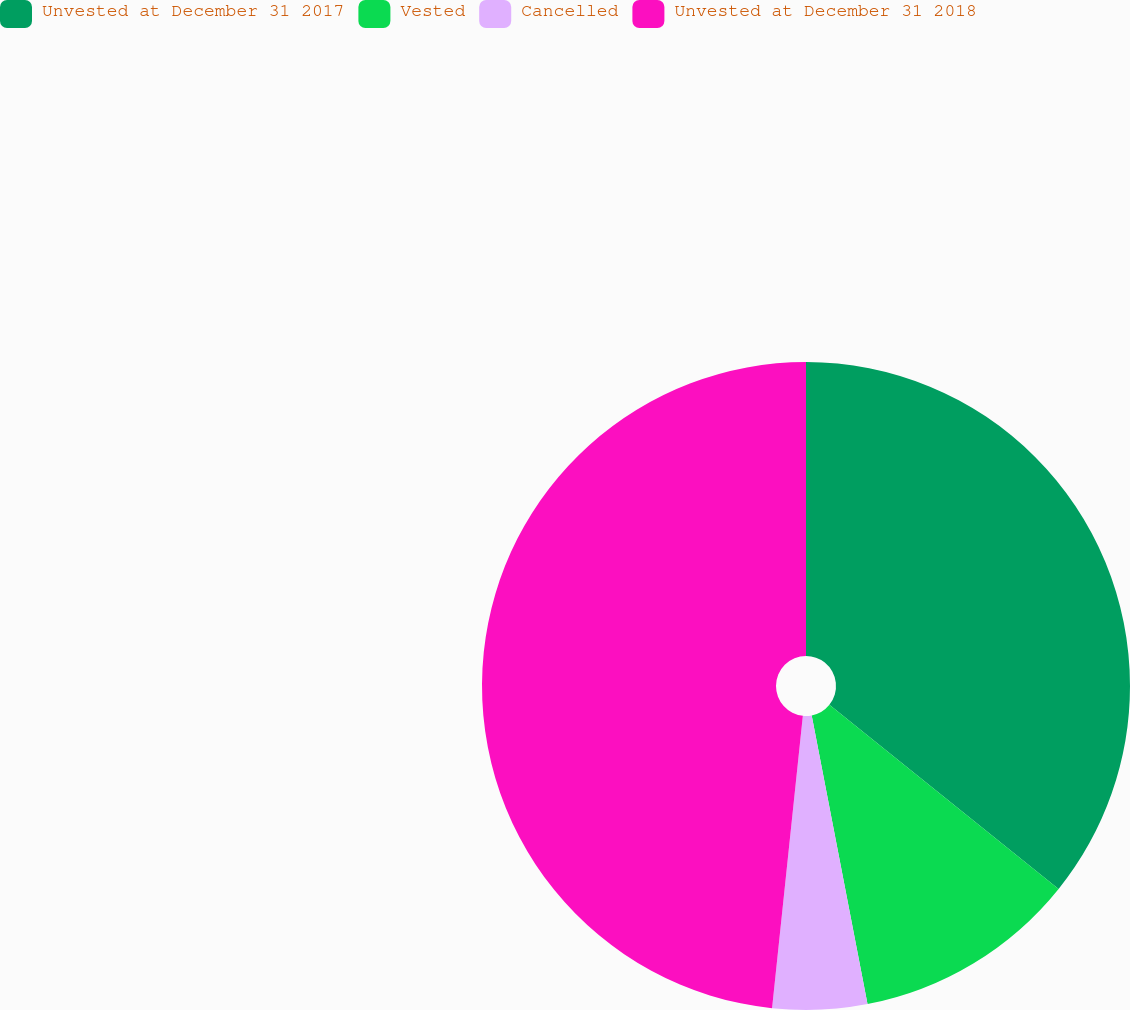Convert chart. <chart><loc_0><loc_0><loc_500><loc_500><pie_chart><fcel>Unvested at December 31 2017<fcel>Vested<fcel>Cancelled<fcel>Unvested at December 31 2018<nl><fcel>35.77%<fcel>11.19%<fcel>4.71%<fcel>48.33%<nl></chart> 